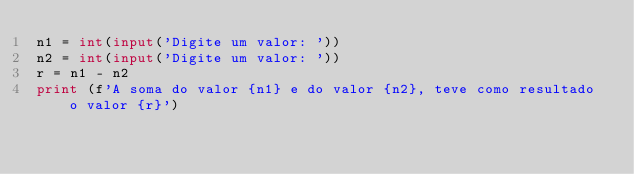<code> <loc_0><loc_0><loc_500><loc_500><_Python_>n1 = int(input('Digite um valor: '))
n2 = int(input('Digite um valor: '))
r = n1 - n2
print (f'A soma do valor {n1} e do valor {n2}, teve como resultado o valor {r}')</code> 